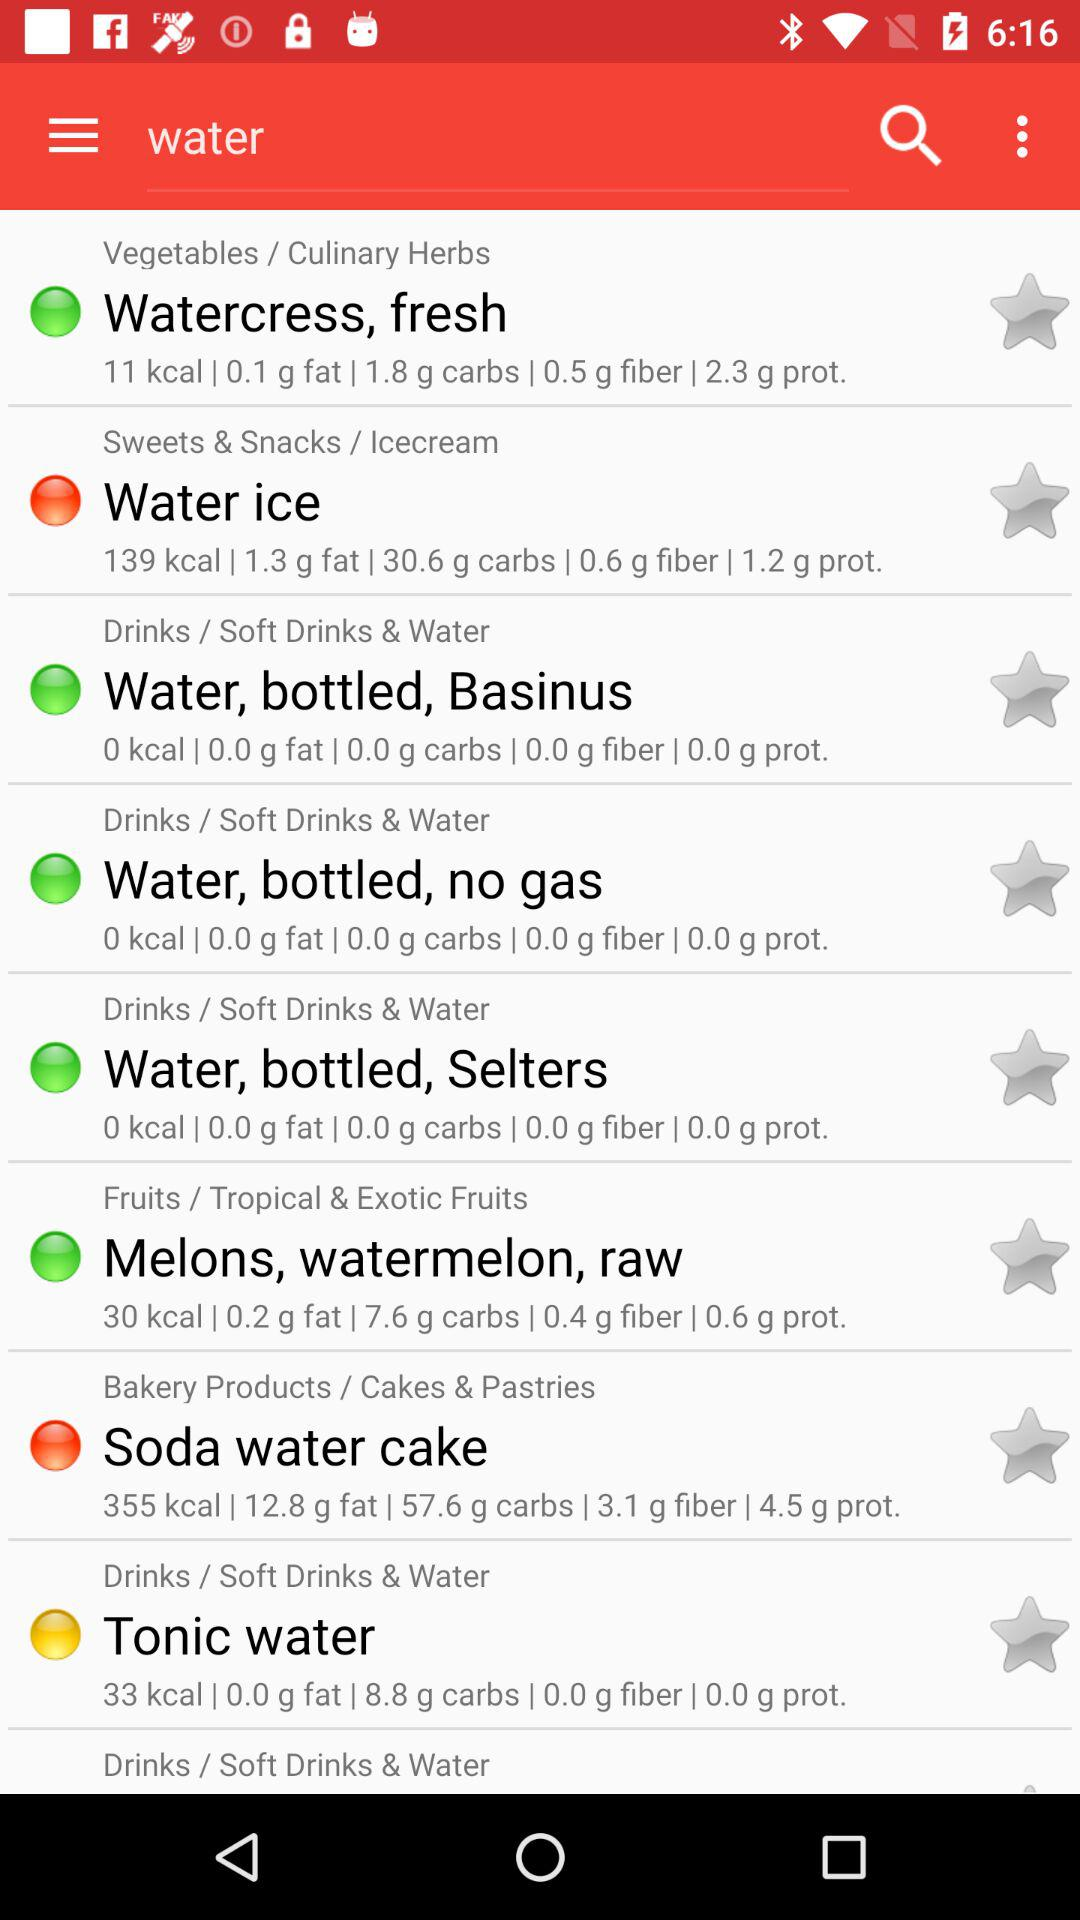How much fat is in "Soda water cake"? The "Soda water cake" contains 12.8 g of fat. 